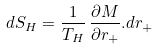Convert formula to latex. <formula><loc_0><loc_0><loc_500><loc_500>d S _ { H } = \frac { 1 } { T _ { H } } \, \frac { \partial M } { \partial r _ { + } } . d r _ { + }</formula> 